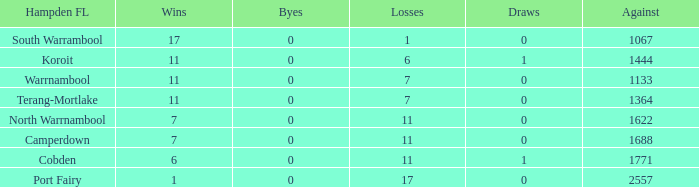What were the losses when the byes were less than 0? None. 